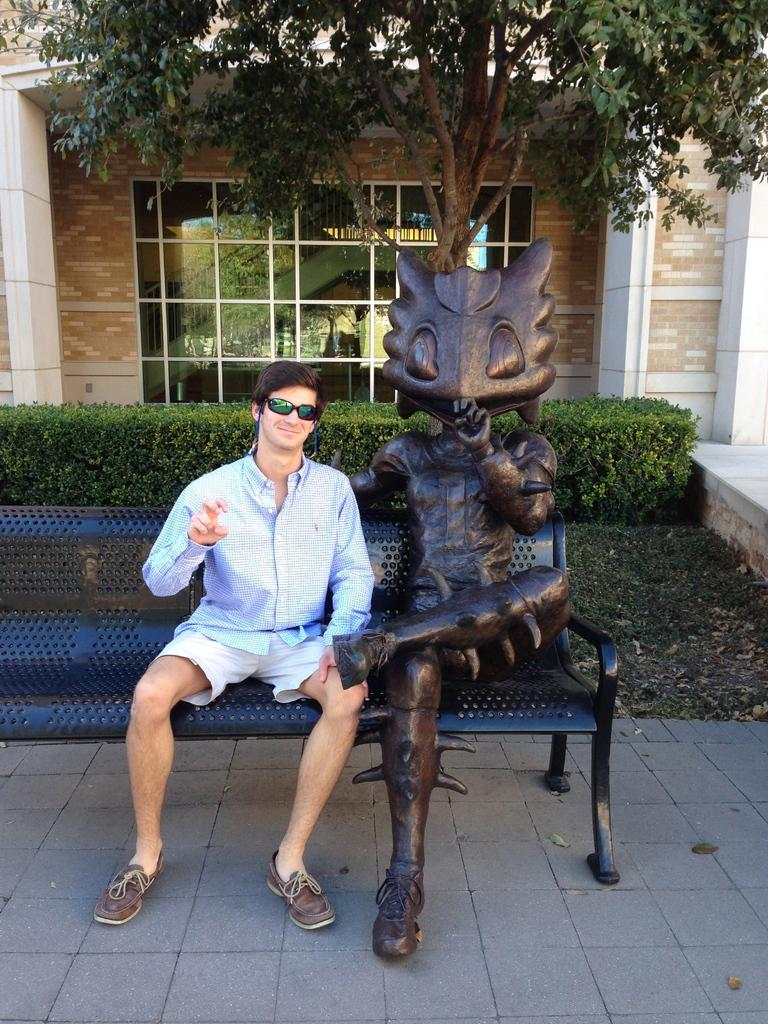What is the person in the image doing? There is a person sitting in the image. What can be seen on the bench in the image? There is a statue on a bench in the image. What is covering the ground in the image? Shredded leaves are present on the ground in the image. What type of vegetation is visible in the image? Bushes are visible in the image. What type of structure is present in the image? There is a building in the image. What type of plant is visible in the image? There is a tree in the image. What type of meal is being prepared by the tree in the image? There is no meal being prepared in the image; the tree is a plant and not involved in food preparation. 